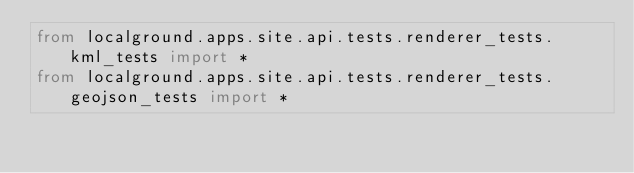Convert code to text. <code><loc_0><loc_0><loc_500><loc_500><_Python_>from localground.apps.site.api.tests.renderer_tests.kml_tests import *
from localground.apps.site.api.tests.renderer_tests.geojson_tests import *</code> 